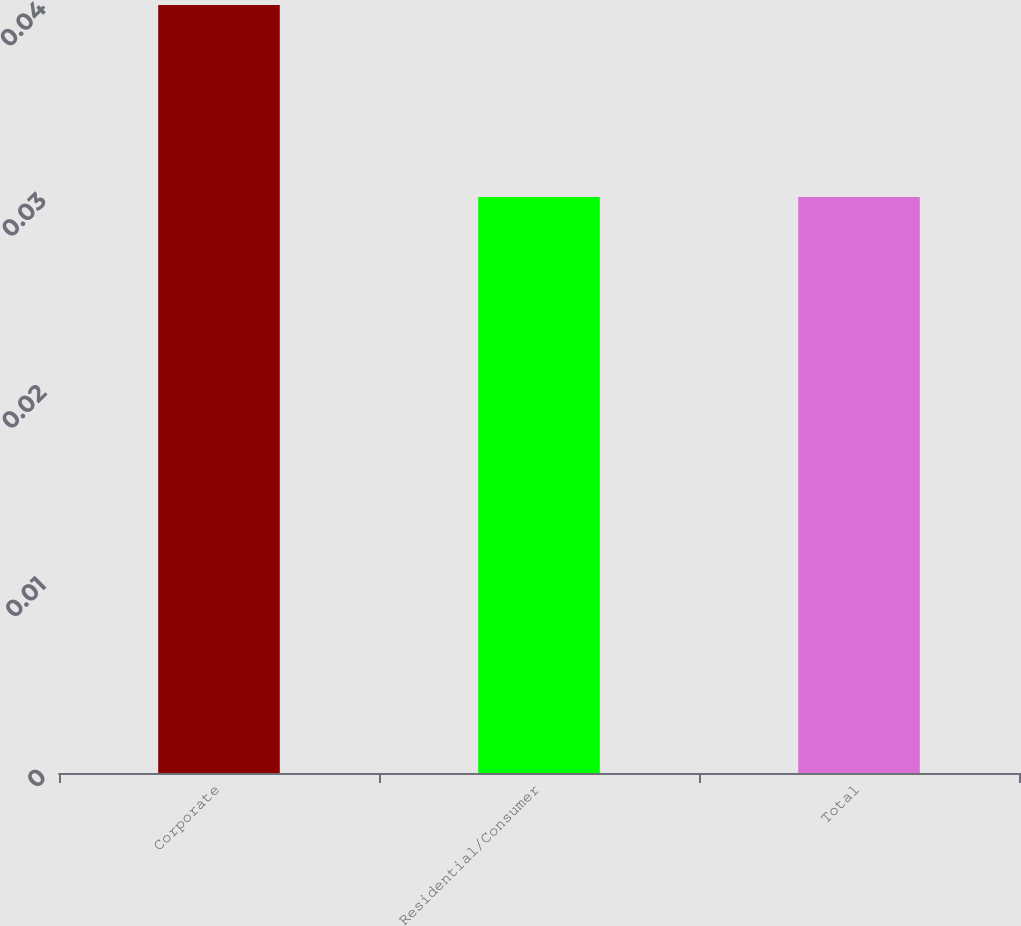Convert chart to OTSL. <chart><loc_0><loc_0><loc_500><loc_500><bar_chart><fcel>Corporate<fcel>Residential/Consumer<fcel>Total<nl><fcel>0.04<fcel>0.03<fcel>0.03<nl></chart> 